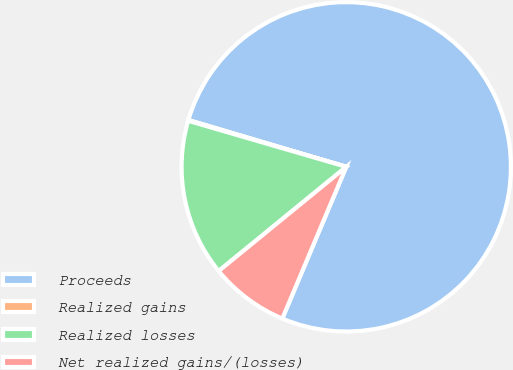Convert chart to OTSL. <chart><loc_0><loc_0><loc_500><loc_500><pie_chart><fcel>Proceeds<fcel>Realized gains<fcel>Realized losses<fcel>Net realized gains/(losses)<nl><fcel>76.76%<fcel>0.08%<fcel>15.41%<fcel>7.75%<nl></chart> 